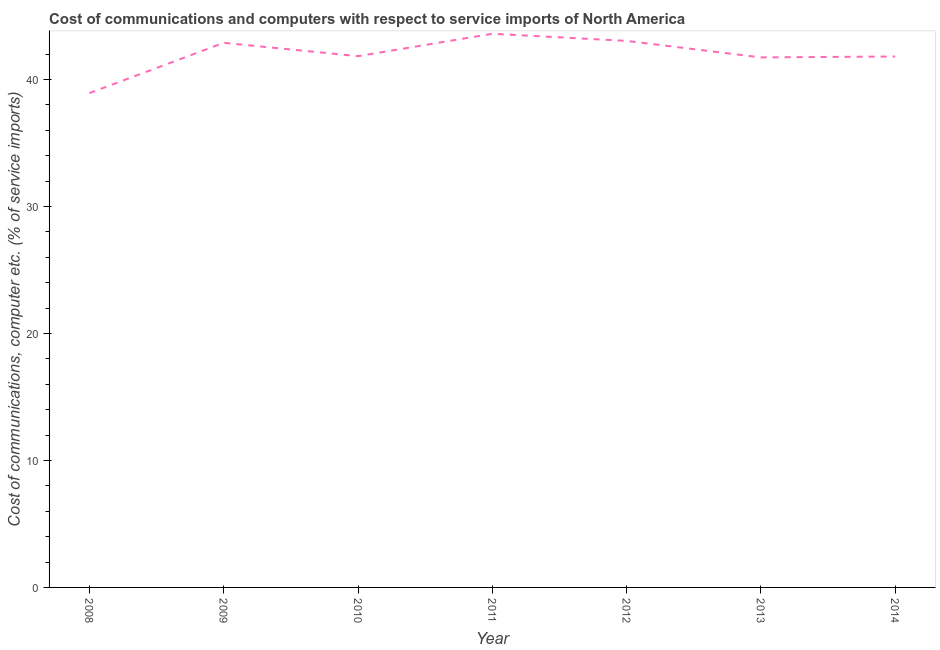What is the cost of communications and computer in 2009?
Make the answer very short. 42.89. Across all years, what is the maximum cost of communications and computer?
Your answer should be compact. 43.61. Across all years, what is the minimum cost of communications and computer?
Your answer should be compact. 38.93. What is the sum of the cost of communications and computer?
Give a very brief answer. 293.89. What is the difference between the cost of communications and computer in 2009 and 2013?
Keep it short and to the point. 1.15. What is the average cost of communications and computer per year?
Your response must be concise. 41.98. What is the median cost of communications and computer?
Make the answer very short. 41.84. Do a majority of the years between 2013 and 2011 (inclusive) have cost of communications and computer greater than 22 %?
Offer a very short reply. No. What is the ratio of the cost of communications and computer in 2010 to that in 2011?
Offer a very short reply. 0.96. Is the difference between the cost of communications and computer in 2010 and 2014 greater than the difference between any two years?
Offer a terse response. No. What is the difference between the highest and the second highest cost of communications and computer?
Offer a very short reply. 0.56. What is the difference between the highest and the lowest cost of communications and computer?
Ensure brevity in your answer.  4.67. In how many years, is the cost of communications and computer greater than the average cost of communications and computer taken over all years?
Make the answer very short. 3. How many years are there in the graph?
Keep it short and to the point. 7. Does the graph contain grids?
Your answer should be very brief. No. What is the title of the graph?
Make the answer very short. Cost of communications and computers with respect to service imports of North America. What is the label or title of the Y-axis?
Ensure brevity in your answer.  Cost of communications, computer etc. (% of service imports). What is the Cost of communications, computer etc. (% of service imports) in 2008?
Provide a succinct answer. 38.93. What is the Cost of communications, computer etc. (% of service imports) of 2009?
Your answer should be very brief. 42.89. What is the Cost of communications, computer etc. (% of service imports) of 2010?
Make the answer very short. 41.84. What is the Cost of communications, computer etc. (% of service imports) of 2011?
Offer a very short reply. 43.61. What is the Cost of communications, computer etc. (% of service imports) in 2012?
Make the answer very short. 43.05. What is the Cost of communications, computer etc. (% of service imports) of 2013?
Make the answer very short. 41.75. What is the Cost of communications, computer etc. (% of service imports) of 2014?
Offer a terse response. 41.82. What is the difference between the Cost of communications, computer etc. (% of service imports) in 2008 and 2009?
Offer a very short reply. -3.96. What is the difference between the Cost of communications, computer etc. (% of service imports) in 2008 and 2010?
Offer a terse response. -2.91. What is the difference between the Cost of communications, computer etc. (% of service imports) in 2008 and 2011?
Offer a terse response. -4.67. What is the difference between the Cost of communications, computer etc. (% of service imports) in 2008 and 2012?
Ensure brevity in your answer.  -4.11. What is the difference between the Cost of communications, computer etc. (% of service imports) in 2008 and 2013?
Offer a terse response. -2.81. What is the difference between the Cost of communications, computer etc. (% of service imports) in 2008 and 2014?
Give a very brief answer. -2.88. What is the difference between the Cost of communications, computer etc. (% of service imports) in 2009 and 2010?
Keep it short and to the point. 1.05. What is the difference between the Cost of communications, computer etc. (% of service imports) in 2009 and 2011?
Keep it short and to the point. -0.71. What is the difference between the Cost of communications, computer etc. (% of service imports) in 2009 and 2012?
Make the answer very short. -0.15. What is the difference between the Cost of communications, computer etc. (% of service imports) in 2009 and 2013?
Provide a succinct answer. 1.15. What is the difference between the Cost of communications, computer etc. (% of service imports) in 2009 and 2014?
Your response must be concise. 1.08. What is the difference between the Cost of communications, computer etc. (% of service imports) in 2010 and 2011?
Make the answer very short. -1.76. What is the difference between the Cost of communications, computer etc. (% of service imports) in 2010 and 2012?
Give a very brief answer. -1.2. What is the difference between the Cost of communications, computer etc. (% of service imports) in 2010 and 2013?
Offer a very short reply. 0.1. What is the difference between the Cost of communications, computer etc. (% of service imports) in 2010 and 2014?
Make the answer very short. 0.03. What is the difference between the Cost of communications, computer etc. (% of service imports) in 2011 and 2012?
Provide a short and direct response. 0.56. What is the difference between the Cost of communications, computer etc. (% of service imports) in 2011 and 2013?
Your response must be concise. 1.86. What is the difference between the Cost of communications, computer etc. (% of service imports) in 2011 and 2014?
Your answer should be very brief. 1.79. What is the difference between the Cost of communications, computer etc. (% of service imports) in 2012 and 2013?
Your answer should be compact. 1.3. What is the difference between the Cost of communications, computer etc. (% of service imports) in 2012 and 2014?
Offer a very short reply. 1.23. What is the difference between the Cost of communications, computer etc. (% of service imports) in 2013 and 2014?
Your response must be concise. -0.07. What is the ratio of the Cost of communications, computer etc. (% of service imports) in 2008 to that in 2009?
Offer a terse response. 0.91. What is the ratio of the Cost of communications, computer etc. (% of service imports) in 2008 to that in 2011?
Provide a short and direct response. 0.89. What is the ratio of the Cost of communications, computer etc. (% of service imports) in 2008 to that in 2012?
Ensure brevity in your answer.  0.9. What is the ratio of the Cost of communications, computer etc. (% of service imports) in 2008 to that in 2013?
Provide a short and direct response. 0.93. What is the ratio of the Cost of communications, computer etc. (% of service imports) in 2008 to that in 2014?
Ensure brevity in your answer.  0.93. What is the ratio of the Cost of communications, computer etc. (% of service imports) in 2009 to that in 2010?
Provide a succinct answer. 1.02. What is the ratio of the Cost of communications, computer etc. (% of service imports) in 2009 to that in 2011?
Give a very brief answer. 0.98. What is the ratio of the Cost of communications, computer etc. (% of service imports) in 2009 to that in 2013?
Your answer should be very brief. 1.03. What is the ratio of the Cost of communications, computer etc. (% of service imports) in 2009 to that in 2014?
Give a very brief answer. 1.03. What is the ratio of the Cost of communications, computer etc. (% of service imports) in 2011 to that in 2012?
Your answer should be very brief. 1.01. What is the ratio of the Cost of communications, computer etc. (% of service imports) in 2011 to that in 2013?
Your response must be concise. 1.04. What is the ratio of the Cost of communications, computer etc. (% of service imports) in 2011 to that in 2014?
Offer a terse response. 1.04. What is the ratio of the Cost of communications, computer etc. (% of service imports) in 2012 to that in 2013?
Give a very brief answer. 1.03. 